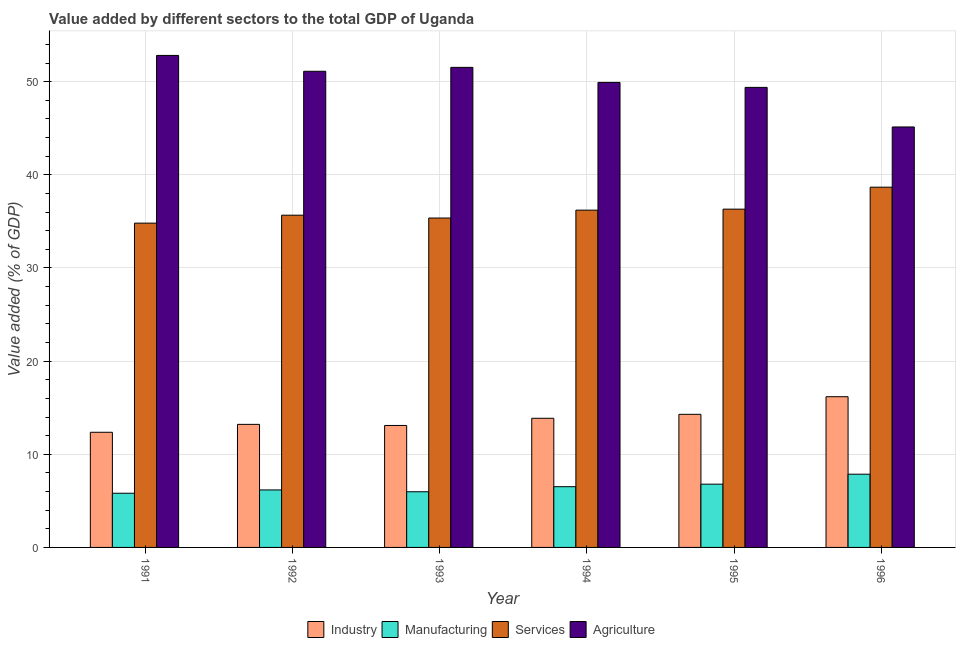How many different coloured bars are there?
Your response must be concise. 4. How many bars are there on the 6th tick from the left?
Your answer should be very brief. 4. How many bars are there on the 2nd tick from the right?
Give a very brief answer. 4. What is the value added by agricultural sector in 1991?
Provide a succinct answer. 52.82. Across all years, what is the maximum value added by manufacturing sector?
Offer a terse response. 7.86. Across all years, what is the minimum value added by agricultural sector?
Provide a short and direct response. 45.14. In which year was the value added by services sector minimum?
Give a very brief answer. 1991. What is the total value added by industrial sector in the graph?
Offer a terse response. 83.01. What is the difference between the value added by agricultural sector in 1993 and that in 1996?
Keep it short and to the point. 6.4. What is the difference between the value added by agricultural sector in 1991 and the value added by services sector in 1996?
Keep it short and to the point. 7.68. What is the average value added by manufacturing sector per year?
Make the answer very short. 6.52. What is the ratio of the value added by manufacturing sector in 1994 to that in 1995?
Give a very brief answer. 0.96. Is the value added by agricultural sector in 1991 less than that in 1996?
Offer a terse response. No. What is the difference between the highest and the second highest value added by services sector?
Make the answer very short. 2.36. What is the difference between the highest and the lowest value added by agricultural sector?
Your answer should be compact. 7.68. Is the sum of the value added by agricultural sector in 1993 and 1995 greater than the maximum value added by industrial sector across all years?
Offer a very short reply. Yes. What does the 4th bar from the left in 1993 represents?
Your response must be concise. Agriculture. What does the 1st bar from the right in 1991 represents?
Make the answer very short. Agriculture. How many bars are there?
Give a very brief answer. 24. Are all the bars in the graph horizontal?
Offer a terse response. No. How many years are there in the graph?
Make the answer very short. 6. How are the legend labels stacked?
Offer a very short reply. Horizontal. What is the title of the graph?
Offer a terse response. Value added by different sectors to the total GDP of Uganda. What is the label or title of the X-axis?
Keep it short and to the point. Year. What is the label or title of the Y-axis?
Make the answer very short. Value added (% of GDP). What is the Value added (% of GDP) of Industry in 1991?
Give a very brief answer. 12.36. What is the Value added (% of GDP) of Manufacturing in 1991?
Keep it short and to the point. 5.82. What is the Value added (% of GDP) of Services in 1991?
Provide a succinct answer. 34.82. What is the Value added (% of GDP) of Agriculture in 1991?
Offer a terse response. 52.82. What is the Value added (% of GDP) in Industry in 1992?
Your answer should be compact. 13.21. What is the Value added (% of GDP) in Manufacturing in 1992?
Keep it short and to the point. 6.17. What is the Value added (% of GDP) of Services in 1992?
Give a very brief answer. 35.67. What is the Value added (% of GDP) of Agriculture in 1992?
Provide a short and direct response. 51.12. What is the Value added (% of GDP) of Industry in 1993?
Keep it short and to the point. 13.09. What is the Value added (% of GDP) of Manufacturing in 1993?
Ensure brevity in your answer.  5.98. What is the Value added (% of GDP) of Services in 1993?
Provide a succinct answer. 35.36. What is the Value added (% of GDP) in Agriculture in 1993?
Offer a terse response. 51.54. What is the Value added (% of GDP) of Industry in 1994?
Offer a very short reply. 13.87. What is the Value added (% of GDP) in Manufacturing in 1994?
Make the answer very short. 6.52. What is the Value added (% of GDP) of Services in 1994?
Offer a very short reply. 36.21. What is the Value added (% of GDP) of Agriculture in 1994?
Give a very brief answer. 49.92. What is the Value added (% of GDP) in Industry in 1995?
Your answer should be compact. 14.29. What is the Value added (% of GDP) in Manufacturing in 1995?
Provide a succinct answer. 6.79. What is the Value added (% of GDP) of Services in 1995?
Ensure brevity in your answer.  36.32. What is the Value added (% of GDP) in Agriculture in 1995?
Provide a succinct answer. 49.39. What is the Value added (% of GDP) of Industry in 1996?
Provide a succinct answer. 16.18. What is the Value added (% of GDP) in Manufacturing in 1996?
Your answer should be very brief. 7.86. What is the Value added (% of GDP) of Services in 1996?
Your response must be concise. 38.68. What is the Value added (% of GDP) in Agriculture in 1996?
Offer a very short reply. 45.14. Across all years, what is the maximum Value added (% of GDP) in Industry?
Provide a succinct answer. 16.18. Across all years, what is the maximum Value added (% of GDP) of Manufacturing?
Provide a succinct answer. 7.86. Across all years, what is the maximum Value added (% of GDP) in Services?
Provide a succinct answer. 38.68. Across all years, what is the maximum Value added (% of GDP) of Agriculture?
Offer a very short reply. 52.82. Across all years, what is the minimum Value added (% of GDP) in Industry?
Your answer should be very brief. 12.36. Across all years, what is the minimum Value added (% of GDP) of Manufacturing?
Your answer should be compact. 5.82. Across all years, what is the minimum Value added (% of GDP) of Services?
Make the answer very short. 34.82. Across all years, what is the minimum Value added (% of GDP) in Agriculture?
Give a very brief answer. 45.14. What is the total Value added (% of GDP) of Industry in the graph?
Your answer should be very brief. 83.01. What is the total Value added (% of GDP) in Manufacturing in the graph?
Your response must be concise. 39.14. What is the total Value added (% of GDP) of Services in the graph?
Offer a very short reply. 217.06. What is the total Value added (% of GDP) of Agriculture in the graph?
Your answer should be very brief. 299.94. What is the difference between the Value added (% of GDP) of Industry in 1991 and that in 1992?
Provide a succinct answer. -0.85. What is the difference between the Value added (% of GDP) in Manufacturing in 1991 and that in 1992?
Your answer should be very brief. -0.36. What is the difference between the Value added (% of GDP) of Services in 1991 and that in 1992?
Provide a short and direct response. -0.85. What is the difference between the Value added (% of GDP) in Agriculture in 1991 and that in 1992?
Offer a very short reply. 1.7. What is the difference between the Value added (% of GDP) of Industry in 1991 and that in 1993?
Provide a short and direct response. -0.73. What is the difference between the Value added (% of GDP) in Manufacturing in 1991 and that in 1993?
Your answer should be very brief. -0.16. What is the difference between the Value added (% of GDP) of Services in 1991 and that in 1993?
Your answer should be compact. -0.55. What is the difference between the Value added (% of GDP) in Agriculture in 1991 and that in 1993?
Your answer should be compact. 1.28. What is the difference between the Value added (% of GDP) of Industry in 1991 and that in 1994?
Offer a very short reply. -1.5. What is the difference between the Value added (% of GDP) in Manufacturing in 1991 and that in 1994?
Give a very brief answer. -0.7. What is the difference between the Value added (% of GDP) of Services in 1991 and that in 1994?
Your answer should be compact. -1.39. What is the difference between the Value added (% of GDP) in Agriculture in 1991 and that in 1994?
Ensure brevity in your answer.  2.9. What is the difference between the Value added (% of GDP) in Industry in 1991 and that in 1995?
Keep it short and to the point. -1.93. What is the difference between the Value added (% of GDP) in Manufacturing in 1991 and that in 1995?
Your response must be concise. -0.97. What is the difference between the Value added (% of GDP) of Services in 1991 and that in 1995?
Keep it short and to the point. -1.5. What is the difference between the Value added (% of GDP) in Agriculture in 1991 and that in 1995?
Offer a terse response. 3.43. What is the difference between the Value added (% of GDP) of Industry in 1991 and that in 1996?
Ensure brevity in your answer.  -3.82. What is the difference between the Value added (% of GDP) in Manufacturing in 1991 and that in 1996?
Offer a terse response. -2.04. What is the difference between the Value added (% of GDP) in Services in 1991 and that in 1996?
Make the answer very short. -3.86. What is the difference between the Value added (% of GDP) of Agriculture in 1991 and that in 1996?
Your answer should be very brief. 7.68. What is the difference between the Value added (% of GDP) of Industry in 1992 and that in 1993?
Make the answer very short. 0.12. What is the difference between the Value added (% of GDP) of Manufacturing in 1992 and that in 1993?
Ensure brevity in your answer.  0.2. What is the difference between the Value added (% of GDP) of Services in 1992 and that in 1993?
Make the answer very short. 0.3. What is the difference between the Value added (% of GDP) in Agriculture in 1992 and that in 1993?
Your answer should be compact. -0.42. What is the difference between the Value added (% of GDP) in Industry in 1992 and that in 1994?
Offer a terse response. -0.65. What is the difference between the Value added (% of GDP) in Manufacturing in 1992 and that in 1994?
Provide a succinct answer. -0.35. What is the difference between the Value added (% of GDP) in Services in 1992 and that in 1994?
Your answer should be very brief. -0.54. What is the difference between the Value added (% of GDP) in Agriculture in 1992 and that in 1994?
Your answer should be compact. 1.2. What is the difference between the Value added (% of GDP) of Industry in 1992 and that in 1995?
Ensure brevity in your answer.  -1.08. What is the difference between the Value added (% of GDP) in Manufacturing in 1992 and that in 1995?
Offer a very short reply. -0.62. What is the difference between the Value added (% of GDP) in Services in 1992 and that in 1995?
Make the answer very short. -0.65. What is the difference between the Value added (% of GDP) in Agriculture in 1992 and that in 1995?
Your response must be concise. 1.73. What is the difference between the Value added (% of GDP) of Industry in 1992 and that in 1996?
Keep it short and to the point. -2.97. What is the difference between the Value added (% of GDP) in Manufacturing in 1992 and that in 1996?
Offer a terse response. -1.69. What is the difference between the Value added (% of GDP) of Services in 1992 and that in 1996?
Offer a terse response. -3.01. What is the difference between the Value added (% of GDP) of Agriculture in 1992 and that in 1996?
Offer a very short reply. 5.98. What is the difference between the Value added (% of GDP) of Industry in 1993 and that in 1994?
Your answer should be very brief. -0.77. What is the difference between the Value added (% of GDP) of Manufacturing in 1993 and that in 1994?
Your answer should be very brief. -0.54. What is the difference between the Value added (% of GDP) of Services in 1993 and that in 1994?
Your response must be concise. -0.85. What is the difference between the Value added (% of GDP) of Agriculture in 1993 and that in 1994?
Make the answer very short. 1.62. What is the difference between the Value added (% of GDP) of Industry in 1993 and that in 1995?
Offer a very short reply. -1.2. What is the difference between the Value added (% of GDP) of Manufacturing in 1993 and that in 1995?
Offer a very short reply. -0.82. What is the difference between the Value added (% of GDP) in Services in 1993 and that in 1995?
Offer a very short reply. -0.95. What is the difference between the Value added (% of GDP) in Agriculture in 1993 and that in 1995?
Keep it short and to the point. 2.15. What is the difference between the Value added (% of GDP) of Industry in 1993 and that in 1996?
Make the answer very short. -3.09. What is the difference between the Value added (% of GDP) of Manufacturing in 1993 and that in 1996?
Offer a terse response. -1.89. What is the difference between the Value added (% of GDP) in Services in 1993 and that in 1996?
Your answer should be very brief. -3.31. What is the difference between the Value added (% of GDP) in Agriculture in 1993 and that in 1996?
Make the answer very short. 6.4. What is the difference between the Value added (% of GDP) in Industry in 1994 and that in 1995?
Give a very brief answer. -0.43. What is the difference between the Value added (% of GDP) of Manufacturing in 1994 and that in 1995?
Offer a terse response. -0.27. What is the difference between the Value added (% of GDP) in Services in 1994 and that in 1995?
Your answer should be very brief. -0.11. What is the difference between the Value added (% of GDP) in Agriculture in 1994 and that in 1995?
Your answer should be compact. 0.53. What is the difference between the Value added (% of GDP) in Industry in 1994 and that in 1996?
Provide a succinct answer. -2.31. What is the difference between the Value added (% of GDP) in Manufacturing in 1994 and that in 1996?
Keep it short and to the point. -1.34. What is the difference between the Value added (% of GDP) of Services in 1994 and that in 1996?
Keep it short and to the point. -2.47. What is the difference between the Value added (% of GDP) in Agriculture in 1994 and that in 1996?
Ensure brevity in your answer.  4.78. What is the difference between the Value added (% of GDP) in Industry in 1995 and that in 1996?
Keep it short and to the point. -1.89. What is the difference between the Value added (% of GDP) of Manufacturing in 1995 and that in 1996?
Provide a succinct answer. -1.07. What is the difference between the Value added (% of GDP) in Services in 1995 and that in 1996?
Provide a short and direct response. -2.36. What is the difference between the Value added (% of GDP) of Agriculture in 1995 and that in 1996?
Your answer should be compact. 4.25. What is the difference between the Value added (% of GDP) of Industry in 1991 and the Value added (% of GDP) of Manufacturing in 1992?
Make the answer very short. 6.19. What is the difference between the Value added (% of GDP) of Industry in 1991 and the Value added (% of GDP) of Services in 1992?
Give a very brief answer. -23.31. What is the difference between the Value added (% of GDP) of Industry in 1991 and the Value added (% of GDP) of Agriculture in 1992?
Your answer should be very brief. -38.76. What is the difference between the Value added (% of GDP) in Manufacturing in 1991 and the Value added (% of GDP) in Services in 1992?
Give a very brief answer. -29.85. What is the difference between the Value added (% of GDP) of Manufacturing in 1991 and the Value added (% of GDP) of Agriculture in 1992?
Provide a short and direct response. -45.3. What is the difference between the Value added (% of GDP) of Services in 1991 and the Value added (% of GDP) of Agriculture in 1992?
Your answer should be very brief. -16.3. What is the difference between the Value added (% of GDP) in Industry in 1991 and the Value added (% of GDP) in Manufacturing in 1993?
Ensure brevity in your answer.  6.39. What is the difference between the Value added (% of GDP) of Industry in 1991 and the Value added (% of GDP) of Services in 1993?
Offer a very short reply. -23. What is the difference between the Value added (% of GDP) of Industry in 1991 and the Value added (% of GDP) of Agriculture in 1993?
Your answer should be compact. -39.18. What is the difference between the Value added (% of GDP) in Manufacturing in 1991 and the Value added (% of GDP) in Services in 1993?
Your answer should be very brief. -29.55. What is the difference between the Value added (% of GDP) of Manufacturing in 1991 and the Value added (% of GDP) of Agriculture in 1993?
Provide a short and direct response. -45.72. What is the difference between the Value added (% of GDP) of Services in 1991 and the Value added (% of GDP) of Agriculture in 1993?
Make the answer very short. -16.72. What is the difference between the Value added (% of GDP) in Industry in 1991 and the Value added (% of GDP) in Manufacturing in 1994?
Make the answer very short. 5.84. What is the difference between the Value added (% of GDP) in Industry in 1991 and the Value added (% of GDP) in Services in 1994?
Give a very brief answer. -23.85. What is the difference between the Value added (% of GDP) in Industry in 1991 and the Value added (% of GDP) in Agriculture in 1994?
Offer a terse response. -37.56. What is the difference between the Value added (% of GDP) of Manufacturing in 1991 and the Value added (% of GDP) of Services in 1994?
Offer a terse response. -30.39. What is the difference between the Value added (% of GDP) of Manufacturing in 1991 and the Value added (% of GDP) of Agriculture in 1994?
Your answer should be compact. -44.11. What is the difference between the Value added (% of GDP) in Services in 1991 and the Value added (% of GDP) in Agriculture in 1994?
Give a very brief answer. -15.11. What is the difference between the Value added (% of GDP) in Industry in 1991 and the Value added (% of GDP) in Manufacturing in 1995?
Your answer should be compact. 5.57. What is the difference between the Value added (% of GDP) in Industry in 1991 and the Value added (% of GDP) in Services in 1995?
Give a very brief answer. -23.96. What is the difference between the Value added (% of GDP) of Industry in 1991 and the Value added (% of GDP) of Agriculture in 1995?
Make the answer very short. -37.03. What is the difference between the Value added (% of GDP) in Manufacturing in 1991 and the Value added (% of GDP) in Services in 1995?
Your answer should be compact. -30.5. What is the difference between the Value added (% of GDP) in Manufacturing in 1991 and the Value added (% of GDP) in Agriculture in 1995?
Give a very brief answer. -43.57. What is the difference between the Value added (% of GDP) in Services in 1991 and the Value added (% of GDP) in Agriculture in 1995?
Offer a terse response. -14.57. What is the difference between the Value added (% of GDP) in Industry in 1991 and the Value added (% of GDP) in Manufacturing in 1996?
Your answer should be very brief. 4.5. What is the difference between the Value added (% of GDP) of Industry in 1991 and the Value added (% of GDP) of Services in 1996?
Give a very brief answer. -26.32. What is the difference between the Value added (% of GDP) in Industry in 1991 and the Value added (% of GDP) in Agriculture in 1996?
Keep it short and to the point. -32.78. What is the difference between the Value added (% of GDP) of Manufacturing in 1991 and the Value added (% of GDP) of Services in 1996?
Your answer should be very brief. -32.86. What is the difference between the Value added (% of GDP) of Manufacturing in 1991 and the Value added (% of GDP) of Agriculture in 1996?
Your response must be concise. -39.32. What is the difference between the Value added (% of GDP) in Services in 1991 and the Value added (% of GDP) in Agriculture in 1996?
Ensure brevity in your answer.  -10.33. What is the difference between the Value added (% of GDP) in Industry in 1992 and the Value added (% of GDP) in Manufacturing in 1993?
Offer a terse response. 7.24. What is the difference between the Value added (% of GDP) of Industry in 1992 and the Value added (% of GDP) of Services in 1993?
Your response must be concise. -22.15. What is the difference between the Value added (% of GDP) of Industry in 1992 and the Value added (% of GDP) of Agriculture in 1993?
Provide a short and direct response. -38.33. What is the difference between the Value added (% of GDP) in Manufacturing in 1992 and the Value added (% of GDP) in Services in 1993?
Ensure brevity in your answer.  -29.19. What is the difference between the Value added (% of GDP) in Manufacturing in 1992 and the Value added (% of GDP) in Agriculture in 1993?
Provide a short and direct response. -45.37. What is the difference between the Value added (% of GDP) of Services in 1992 and the Value added (% of GDP) of Agriculture in 1993?
Ensure brevity in your answer.  -15.87. What is the difference between the Value added (% of GDP) of Industry in 1992 and the Value added (% of GDP) of Manufacturing in 1994?
Provide a short and direct response. 6.69. What is the difference between the Value added (% of GDP) in Industry in 1992 and the Value added (% of GDP) in Services in 1994?
Your response must be concise. -23. What is the difference between the Value added (% of GDP) of Industry in 1992 and the Value added (% of GDP) of Agriculture in 1994?
Provide a succinct answer. -36.71. What is the difference between the Value added (% of GDP) of Manufacturing in 1992 and the Value added (% of GDP) of Services in 1994?
Provide a short and direct response. -30.04. What is the difference between the Value added (% of GDP) of Manufacturing in 1992 and the Value added (% of GDP) of Agriculture in 1994?
Give a very brief answer. -43.75. What is the difference between the Value added (% of GDP) of Services in 1992 and the Value added (% of GDP) of Agriculture in 1994?
Provide a succinct answer. -14.26. What is the difference between the Value added (% of GDP) of Industry in 1992 and the Value added (% of GDP) of Manufacturing in 1995?
Your answer should be compact. 6.42. What is the difference between the Value added (% of GDP) of Industry in 1992 and the Value added (% of GDP) of Services in 1995?
Ensure brevity in your answer.  -23.11. What is the difference between the Value added (% of GDP) of Industry in 1992 and the Value added (% of GDP) of Agriculture in 1995?
Ensure brevity in your answer.  -36.18. What is the difference between the Value added (% of GDP) of Manufacturing in 1992 and the Value added (% of GDP) of Services in 1995?
Your answer should be compact. -30.14. What is the difference between the Value added (% of GDP) in Manufacturing in 1992 and the Value added (% of GDP) in Agriculture in 1995?
Offer a terse response. -43.22. What is the difference between the Value added (% of GDP) of Services in 1992 and the Value added (% of GDP) of Agriculture in 1995?
Your response must be concise. -13.72. What is the difference between the Value added (% of GDP) of Industry in 1992 and the Value added (% of GDP) of Manufacturing in 1996?
Ensure brevity in your answer.  5.35. What is the difference between the Value added (% of GDP) of Industry in 1992 and the Value added (% of GDP) of Services in 1996?
Provide a succinct answer. -25.47. What is the difference between the Value added (% of GDP) in Industry in 1992 and the Value added (% of GDP) in Agriculture in 1996?
Ensure brevity in your answer.  -31.93. What is the difference between the Value added (% of GDP) in Manufacturing in 1992 and the Value added (% of GDP) in Services in 1996?
Provide a short and direct response. -32.5. What is the difference between the Value added (% of GDP) in Manufacturing in 1992 and the Value added (% of GDP) in Agriculture in 1996?
Offer a very short reply. -38.97. What is the difference between the Value added (% of GDP) in Services in 1992 and the Value added (% of GDP) in Agriculture in 1996?
Your answer should be very brief. -9.47. What is the difference between the Value added (% of GDP) of Industry in 1993 and the Value added (% of GDP) of Manufacturing in 1994?
Offer a terse response. 6.57. What is the difference between the Value added (% of GDP) of Industry in 1993 and the Value added (% of GDP) of Services in 1994?
Provide a short and direct response. -23.12. What is the difference between the Value added (% of GDP) in Industry in 1993 and the Value added (% of GDP) in Agriculture in 1994?
Make the answer very short. -36.83. What is the difference between the Value added (% of GDP) in Manufacturing in 1993 and the Value added (% of GDP) in Services in 1994?
Ensure brevity in your answer.  -30.23. What is the difference between the Value added (% of GDP) in Manufacturing in 1993 and the Value added (% of GDP) in Agriculture in 1994?
Keep it short and to the point. -43.95. What is the difference between the Value added (% of GDP) of Services in 1993 and the Value added (% of GDP) of Agriculture in 1994?
Offer a terse response. -14.56. What is the difference between the Value added (% of GDP) in Industry in 1993 and the Value added (% of GDP) in Manufacturing in 1995?
Make the answer very short. 6.3. What is the difference between the Value added (% of GDP) of Industry in 1993 and the Value added (% of GDP) of Services in 1995?
Ensure brevity in your answer.  -23.22. What is the difference between the Value added (% of GDP) of Industry in 1993 and the Value added (% of GDP) of Agriculture in 1995?
Give a very brief answer. -36.3. What is the difference between the Value added (% of GDP) of Manufacturing in 1993 and the Value added (% of GDP) of Services in 1995?
Make the answer very short. -30.34. What is the difference between the Value added (% of GDP) of Manufacturing in 1993 and the Value added (% of GDP) of Agriculture in 1995?
Offer a very short reply. -43.41. What is the difference between the Value added (% of GDP) in Services in 1993 and the Value added (% of GDP) in Agriculture in 1995?
Offer a very short reply. -14.03. What is the difference between the Value added (% of GDP) of Industry in 1993 and the Value added (% of GDP) of Manufacturing in 1996?
Your answer should be very brief. 5.23. What is the difference between the Value added (% of GDP) in Industry in 1993 and the Value added (% of GDP) in Services in 1996?
Make the answer very short. -25.58. What is the difference between the Value added (% of GDP) of Industry in 1993 and the Value added (% of GDP) of Agriculture in 1996?
Offer a very short reply. -32.05. What is the difference between the Value added (% of GDP) in Manufacturing in 1993 and the Value added (% of GDP) in Services in 1996?
Give a very brief answer. -32.7. What is the difference between the Value added (% of GDP) in Manufacturing in 1993 and the Value added (% of GDP) in Agriculture in 1996?
Provide a succinct answer. -39.17. What is the difference between the Value added (% of GDP) of Services in 1993 and the Value added (% of GDP) of Agriculture in 1996?
Offer a very short reply. -9.78. What is the difference between the Value added (% of GDP) in Industry in 1994 and the Value added (% of GDP) in Manufacturing in 1995?
Your answer should be compact. 7.07. What is the difference between the Value added (% of GDP) of Industry in 1994 and the Value added (% of GDP) of Services in 1995?
Provide a short and direct response. -22.45. What is the difference between the Value added (% of GDP) of Industry in 1994 and the Value added (% of GDP) of Agriculture in 1995?
Offer a terse response. -35.52. What is the difference between the Value added (% of GDP) of Manufacturing in 1994 and the Value added (% of GDP) of Services in 1995?
Offer a very short reply. -29.8. What is the difference between the Value added (% of GDP) of Manufacturing in 1994 and the Value added (% of GDP) of Agriculture in 1995?
Provide a succinct answer. -42.87. What is the difference between the Value added (% of GDP) of Services in 1994 and the Value added (% of GDP) of Agriculture in 1995?
Ensure brevity in your answer.  -13.18. What is the difference between the Value added (% of GDP) in Industry in 1994 and the Value added (% of GDP) in Manufacturing in 1996?
Offer a terse response. 6. What is the difference between the Value added (% of GDP) of Industry in 1994 and the Value added (% of GDP) of Services in 1996?
Give a very brief answer. -24.81. What is the difference between the Value added (% of GDP) of Industry in 1994 and the Value added (% of GDP) of Agriculture in 1996?
Make the answer very short. -31.28. What is the difference between the Value added (% of GDP) in Manufacturing in 1994 and the Value added (% of GDP) in Services in 1996?
Offer a very short reply. -32.16. What is the difference between the Value added (% of GDP) of Manufacturing in 1994 and the Value added (% of GDP) of Agriculture in 1996?
Your response must be concise. -38.62. What is the difference between the Value added (% of GDP) in Services in 1994 and the Value added (% of GDP) in Agriculture in 1996?
Provide a short and direct response. -8.93. What is the difference between the Value added (% of GDP) of Industry in 1995 and the Value added (% of GDP) of Manufacturing in 1996?
Your answer should be compact. 6.43. What is the difference between the Value added (% of GDP) in Industry in 1995 and the Value added (% of GDP) in Services in 1996?
Offer a terse response. -24.39. What is the difference between the Value added (% of GDP) in Industry in 1995 and the Value added (% of GDP) in Agriculture in 1996?
Offer a terse response. -30.85. What is the difference between the Value added (% of GDP) of Manufacturing in 1995 and the Value added (% of GDP) of Services in 1996?
Offer a terse response. -31.88. What is the difference between the Value added (% of GDP) in Manufacturing in 1995 and the Value added (% of GDP) in Agriculture in 1996?
Offer a very short reply. -38.35. What is the difference between the Value added (% of GDP) of Services in 1995 and the Value added (% of GDP) of Agriculture in 1996?
Your answer should be very brief. -8.82. What is the average Value added (% of GDP) in Industry per year?
Give a very brief answer. 13.83. What is the average Value added (% of GDP) in Manufacturing per year?
Provide a short and direct response. 6.52. What is the average Value added (% of GDP) of Services per year?
Offer a terse response. 36.18. What is the average Value added (% of GDP) in Agriculture per year?
Keep it short and to the point. 49.99. In the year 1991, what is the difference between the Value added (% of GDP) in Industry and Value added (% of GDP) in Manufacturing?
Give a very brief answer. 6.54. In the year 1991, what is the difference between the Value added (% of GDP) of Industry and Value added (% of GDP) of Services?
Provide a short and direct response. -22.45. In the year 1991, what is the difference between the Value added (% of GDP) in Industry and Value added (% of GDP) in Agriculture?
Your answer should be compact. -40.46. In the year 1991, what is the difference between the Value added (% of GDP) of Manufacturing and Value added (% of GDP) of Services?
Provide a succinct answer. -29. In the year 1991, what is the difference between the Value added (% of GDP) in Manufacturing and Value added (% of GDP) in Agriculture?
Your response must be concise. -47. In the year 1991, what is the difference between the Value added (% of GDP) in Services and Value added (% of GDP) in Agriculture?
Offer a very short reply. -18.01. In the year 1992, what is the difference between the Value added (% of GDP) in Industry and Value added (% of GDP) in Manufacturing?
Your answer should be compact. 7.04. In the year 1992, what is the difference between the Value added (% of GDP) in Industry and Value added (% of GDP) in Services?
Your answer should be very brief. -22.46. In the year 1992, what is the difference between the Value added (% of GDP) of Industry and Value added (% of GDP) of Agriculture?
Offer a very short reply. -37.91. In the year 1992, what is the difference between the Value added (% of GDP) in Manufacturing and Value added (% of GDP) in Services?
Your answer should be very brief. -29.49. In the year 1992, what is the difference between the Value added (% of GDP) of Manufacturing and Value added (% of GDP) of Agriculture?
Offer a terse response. -44.95. In the year 1992, what is the difference between the Value added (% of GDP) of Services and Value added (% of GDP) of Agriculture?
Your answer should be compact. -15.45. In the year 1993, what is the difference between the Value added (% of GDP) in Industry and Value added (% of GDP) in Manufacturing?
Make the answer very short. 7.12. In the year 1993, what is the difference between the Value added (% of GDP) in Industry and Value added (% of GDP) in Services?
Your answer should be compact. -22.27. In the year 1993, what is the difference between the Value added (% of GDP) of Industry and Value added (% of GDP) of Agriculture?
Offer a terse response. -38.45. In the year 1993, what is the difference between the Value added (% of GDP) of Manufacturing and Value added (% of GDP) of Services?
Ensure brevity in your answer.  -29.39. In the year 1993, what is the difference between the Value added (% of GDP) in Manufacturing and Value added (% of GDP) in Agriculture?
Provide a succinct answer. -45.56. In the year 1993, what is the difference between the Value added (% of GDP) in Services and Value added (% of GDP) in Agriculture?
Keep it short and to the point. -16.18. In the year 1994, what is the difference between the Value added (% of GDP) of Industry and Value added (% of GDP) of Manufacturing?
Your answer should be compact. 7.35. In the year 1994, what is the difference between the Value added (% of GDP) of Industry and Value added (% of GDP) of Services?
Offer a terse response. -22.34. In the year 1994, what is the difference between the Value added (% of GDP) in Industry and Value added (% of GDP) in Agriculture?
Your answer should be compact. -36.06. In the year 1994, what is the difference between the Value added (% of GDP) of Manufacturing and Value added (% of GDP) of Services?
Your answer should be compact. -29.69. In the year 1994, what is the difference between the Value added (% of GDP) in Manufacturing and Value added (% of GDP) in Agriculture?
Provide a succinct answer. -43.4. In the year 1994, what is the difference between the Value added (% of GDP) of Services and Value added (% of GDP) of Agriculture?
Ensure brevity in your answer.  -13.71. In the year 1995, what is the difference between the Value added (% of GDP) of Industry and Value added (% of GDP) of Manufacturing?
Your answer should be compact. 7.5. In the year 1995, what is the difference between the Value added (% of GDP) of Industry and Value added (% of GDP) of Services?
Give a very brief answer. -22.03. In the year 1995, what is the difference between the Value added (% of GDP) of Industry and Value added (% of GDP) of Agriculture?
Your answer should be compact. -35.1. In the year 1995, what is the difference between the Value added (% of GDP) in Manufacturing and Value added (% of GDP) in Services?
Provide a short and direct response. -29.53. In the year 1995, what is the difference between the Value added (% of GDP) of Manufacturing and Value added (% of GDP) of Agriculture?
Your answer should be very brief. -42.6. In the year 1995, what is the difference between the Value added (% of GDP) in Services and Value added (% of GDP) in Agriculture?
Your answer should be compact. -13.07. In the year 1996, what is the difference between the Value added (% of GDP) of Industry and Value added (% of GDP) of Manufacturing?
Keep it short and to the point. 8.32. In the year 1996, what is the difference between the Value added (% of GDP) in Industry and Value added (% of GDP) in Services?
Provide a short and direct response. -22.5. In the year 1996, what is the difference between the Value added (% of GDP) in Industry and Value added (% of GDP) in Agriculture?
Offer a very short reply. -28.96. In the year 1996, what is the difference between the Value added (% of GDP) of Manufacturing and Value added (% of GDP) of Services?
Offer a very short reply. -30.82. In the year 1996, what is the difference between the Value added (% of GDP) in Manufacturing and Value added (% of GDP) in Agriculture?
Offer a very short reply. -37.28. In the year 1996, what is the difference between the Value added (% of GDP) of Services and Value added (% of GDP) of Agriculture?
Your response must be concise. -6.46. What is the ratio of the Value added (% of GDP) of Industry in 1991 to that in 1992?
Offer a very short reply. 0.94. What is the ratio of the Value added (% of GDP) in Manufacturing in 1991 to that in 1992?
Ensure brevity in your answer.  0.94. What is the ratio of the Value added (% of GDP) in Services in 1991 to that in 1992?
Ensure brevity in your answer.  0.98. What is the ratio of the Value added (% of GDP) in Industry in 1991 to that in 1993?
Provide a succinct answer. 0.94. What is the ratio of the Value added (% of GDP) of Manufacturing in 1991 to that in 1993?
Your response must be concise. 0.97. What is the ratio of the Value added (% of GDP) in Services in 1991 to that in 1993?
Your answer should be compact. 0.98. What is the ratio of the Value added (% of GDP) of Agriculture in 1991 to that in 1993?
Keep it short and to the point. 1.02. What is the ratio of the Value added (% of GDP) of Industry in 1991 to that in 1994?
Give a very brief answer. 0.89. What is the ratio of the Value added (% of GDP) of Manufacturing in 1991 to that in 1994?
Your answer should be very brief. 0.89. What is the ratio of the Value added (% of GDP) of Services in 1991 to that in 1994?
Your answer should be compact. 0.96. What is the ratio of the Value added (% of GDP) of Agriculture in 1991 to that in 1994?
Make the answer very short. 1.06. What is the ratio of the Value added (% of GDP) in Industry in 1991 to that in 1995?
Offer a terse response. 0.86. What is the ratio of the Value added (% of GDP) in Manufacturing in 1991 to that in 1995?
Offer a very short reply. 0.86. What is the ratio of the Value added (% of GDP) of Services in 1991 to that in 1995?
Offer a terse response. 0.96. What is the ratio of the Value added (% of GDP) of Agriculture in 1991 to that in 1995?
Give a very brief answer. 1.07. What is the ratio of the Value added (% of GDP) of Industry in 1991 to that in 1996?
Your answer should be very brief. 0.76. What is the ratio of the Value added (% of GDP) of Manufacturing in 1991 to that in 1996?
Provide a succinct answer. 0.74. What is the ratio of the Value added (% of GDP) of Services in 1991 to that in 1996?
Keep it short and to the point. 0.9. What is the ratio of the Value added (% of GDP) of Agriculture in 1991 to that in 1996?
Offer a very short reply. 1.17. What is the ratio of the Value added (% of GDP) in Industry in 1992 to that in 1993?
Give a very brief answer. 1.01. What is the ratio of the Value added (% of GDP) of Manufacturing in 1992 to that in 1993?
Ensure brevity in your answer.  1.03. What is the ratio of the Value added (% of GDP) in Services in 1992 to that in 1993?
Offer a very short reply. 1.01. What is the ratio of the Value added (% of GDP) of Industry in 1992 to that in 1994?
Your response must be concise. 0.95. What is the ratio of the Value added (% of GDP) in Manufacturing in 1992 to that in 1994?
Offer a very short reply. 0.95. What is the ratio of the Value added (% of GDP) in Agriculture in 1992 to that in 1994?
Make the answer very short. 1.02. What is the ratio of the Value added (% of GDP) in Industry in 1992 to that in 1995?
Offer a very short reply. 0.92. What is the ratio of the Value added (% of GDP) of Manufacturing in 1992 to that in 1995?
Ensure brevity in your answer.  0.91. What is the ratio of the Value added (% of GDP) of Services in 1992 to that in 1995?
Provide a succinct answer. 0.98. What is the ratio of the Value added (% of GDP) of Agriculture in 1992 to that in 1995?
Keep it short and to the point. 1.03. What is the ratio of the Value added (% of GDP) of Industry in 1992 to that in 1996?
Make the answer very short. 0.82. What is the ratio of the Value added (% of GDP) in Manufacturing in 1992 to that in 1996?
Your answer should be very brief. 0.79. What is the ratio of the Value added (% of GDP) of Services in 1992 to that in 1996?
Offer a very short reply. 0.92. What is the ratio of the Value added (% of GDP) in Agriculture in 1992 to that in 1996?
Give a very brief answer. 1.13. What is the ratio of the Value added (% of GDP) in Manufacturing in 1993 to that in 1994?
Give a very brief answer. 0.92. What is the ratio of the Value added (% of GDP) of Services in 1993 to that in 1994?
Provide a short and direct response. 0.98. What is the ratio of the Value added (% of GDP) in Agriculture in 1993 to that in 1994?
Provide a succinct answer. 1.03. What is the ratio of the Value added (% of GDP) of Industry in 1993 to that in 1995?
Make the answer very short. 0.92. What is the ratio of the Value added (% of GDP) in Manufacturing in 1993 to that in 1995?
Your answer should be very brief. 0.88. What is the ratio of the Value added (% of GDP) in Services in 1993 to that in 1995?
Provide a succinct answer. 0.97. What is the ratio of the Value added (% of GDP) in Agriculture in 1993 to that in 1995?
Make the answer very short. 1.04. What is the ratio of the Value added (% of GDP) in Industry in 1993 to that in 1996?
Offer a very short reply. 0.81. What is the ratio of the Value added (% of GDP) of Manufacturing in 1993 to that in 1996?
Keep it short and to the point. 0.76. What is the ratio of the Value added (% of GDP) in Services in 1993 to that in 1996?
Offer a terse response. 0.91. What is the ratio of the Value added (% of GDP) of Agriculture in 1993 to that in 1996?
Make the answer very short. 1.14. What is the ratio of the Value added (% of GDP) of Industry in 1994 to that in 1995?
Keep it short and to the point. 0.97. What is the ratio of the Value added (% of GDP) in Services in 1994 to that in 1995?
Offer a very short reply. 1. What is the ratio of the Value added (% of GDP) of Agriculture in 1994 to that in 1995?
Your answer should be compact. 1.01. What is the ratio of the Value added (% of GDP) of Industry in 1994 to that in 1996?
Make the answer very short. 0.86. What is the ratio of the Value added (% of GDP) of Manufacturing in 1994 to that in 1996?
Make the answer very short. 0.83. What is the ratio of the Value added (% of GDP) in Services in 1994 to that in 1996?
Offer a terse response. 0.94. What is the ratio of the Value added (% of GDP) of Agriculture in 1994 to that in 1996?
Make the answer very short. 1.11. What is the ratio of the Value added (% of GDP) of Industry in 1995 to that in 1996?
Give a very brief answer. 0.88. What is the ratio of the Value added (% of GDP) of Manufacturing in 1995 to that in 1996?
Ensure brevity in your answer.  0.86. What is the ratio of the Value added (% of GDP) in Services in 1995 to that in 1996?
Provide a succinct answer. 0.94. What is the ratio of the Value added (% of GDP) of Agriculture in 1995 to that in 1996?
Keep it short and to the point. 1.09. What is the difference between the highest and the second highest Value added (% of GDP) of Industry?
Provide a short and direct response. 1.89. What is the difference between the highest and the second highest Value added (% of GDP) of Manufacturing?
Ensure brevity in your answer.  1.07. What is the difference between the highest and the second highest Value added (% of GDP) in Services?
Provide a succinct answer. 2.36. What is the difference between the highest and the second highest Value added (% of GDP) of Agriculture?
Make the answer very short. 1.28. What is the difference between the highest and the lowest Value added (% of GDP) in Industry?
Make the answer very short. 3.82. What is the difference between the highest and the lowest Value added (% of GDP) of Manufacturing?
Provide a short and direct response. 2.04. What is the difference between the highest and the lowest Value added (% of GDP) in Services?
Your answer should be very brief. 3.86. What is the difference between the highest and the lowest Value added (% of GDP) in Agriculture?
Your response must be concise. 7.68. 